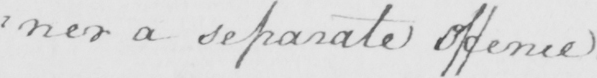What does this handwritten line say? : ner a separate offence . 